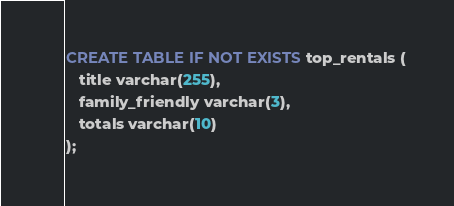<code> <loc_0><loc_0><loc_500><loc_500><_SQL_>CREATE TABLE IF NOT EXISTS top_rentals (
   title varchar(255),
   family_friendly varchar(3),
   totals varchar(10)
);</code> 